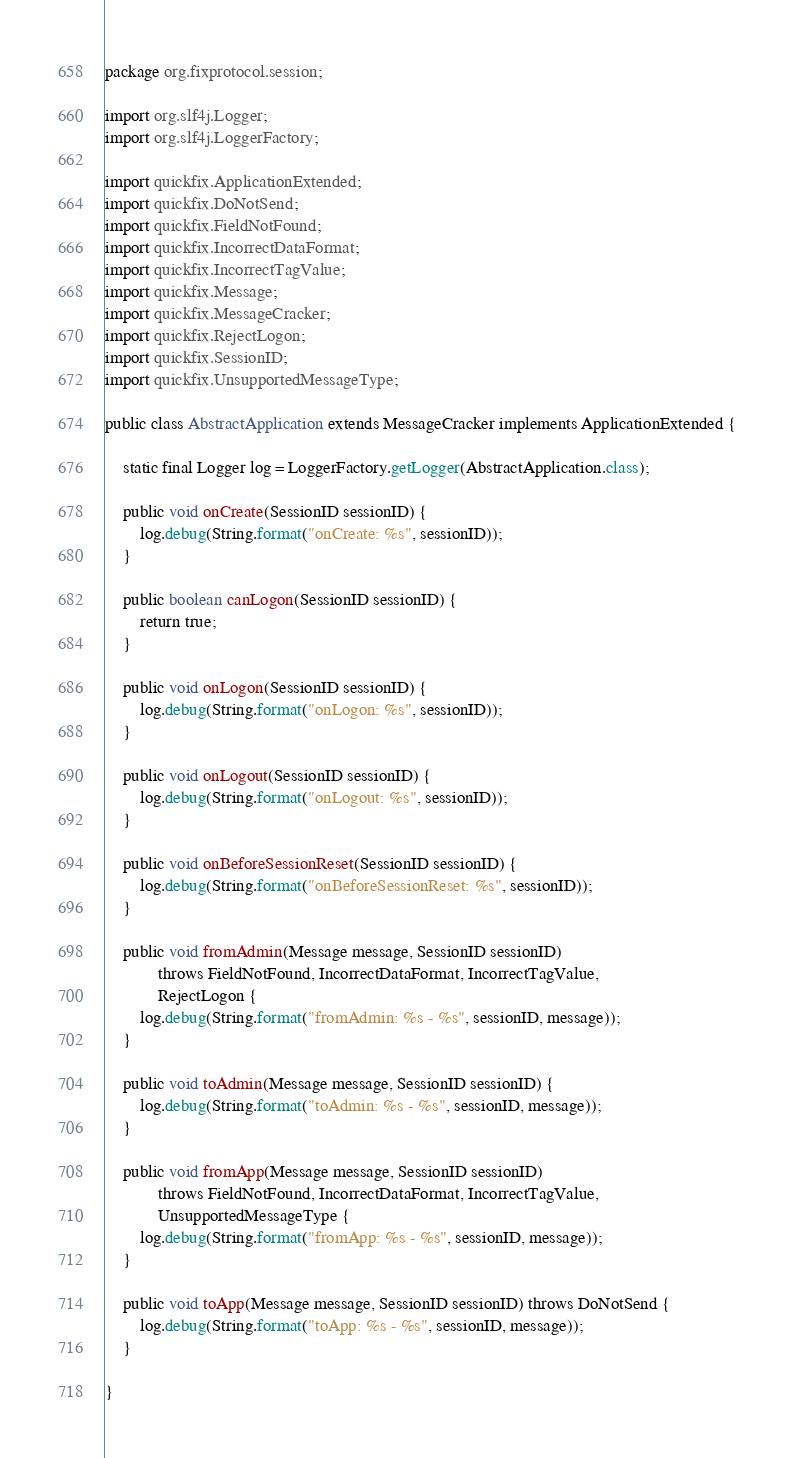<code> <loc_0><loc_0><loc_500><loc_500><_Java_>package org.fixprotocol.session;

import org.slf4j.Logger;
import org.slf4j.LoggerFactory;

import quickfix.ApplicationExtended;
import quickfix.DoNotSend;
import quickfix.FieldNotFound;
import quickfix.IncorrectDataFormat;
import quickfix.IncorrectTagValue;
import quickfix.Message;
import quickfix.MessageCracker;
import quickfix.RejectLogon;
import quickfix.SessionID;
import quickfix.UnsupportedMessageType;

public class AbstractApplication extends MessageCracker implements ApplicationExtended {

	static final Logger log = LoggerFactory.getLogger(AbstractApplication.class);

	public void onCreate(SessionID sessionID) {
		log.debug(String.format("onCreate: %s", sessionID));
	}

	public boolean canLogon(SessionID sessionID) {
		return true;
	}

	public void onLogon(SessionID sessionID) {
		log.debug(String.format("onLogon: %s", sessionID));
	}

	public void onLogout(SessionID sessionID) {
		log.debug(String.format("onLogout: %s", sessionID));
	}

	public void onBeforeSessionReset(SessionID sessionID) {
		log.debug(String.format("onBeforeSessionReset: %s", sessionID));
	}

	public void fromAdmin(Message message, SessionID sessionID)
			throws FieldNotFound, IncorrectDataFormat, IncorrectTagValue,
			RejectLogon {
		log.debug(String.format("fromAdmin: %s - %s", sessionID, message));
	}

	public void toAdmin(Message message, SessionID sessionID) {
		log.debug(String.format("toAdmin: %s - %s", sessionID, message));
	}

	public void fromApp(Message message, SessionID sessionID)
			throws FieldNotFound, IncorrectDataFormat, IncorrectTagValue,
			UnsupportedMessageType {
		log.debug(String.format("fromApp: %s - %s", sessionID, message));
	}

	public void toApp(Message message, SessionID sessionID) throws DoNotSend {
		log.debug(String.format("toApp: %s - %s", sessionID, message));
	}

}
</code> 